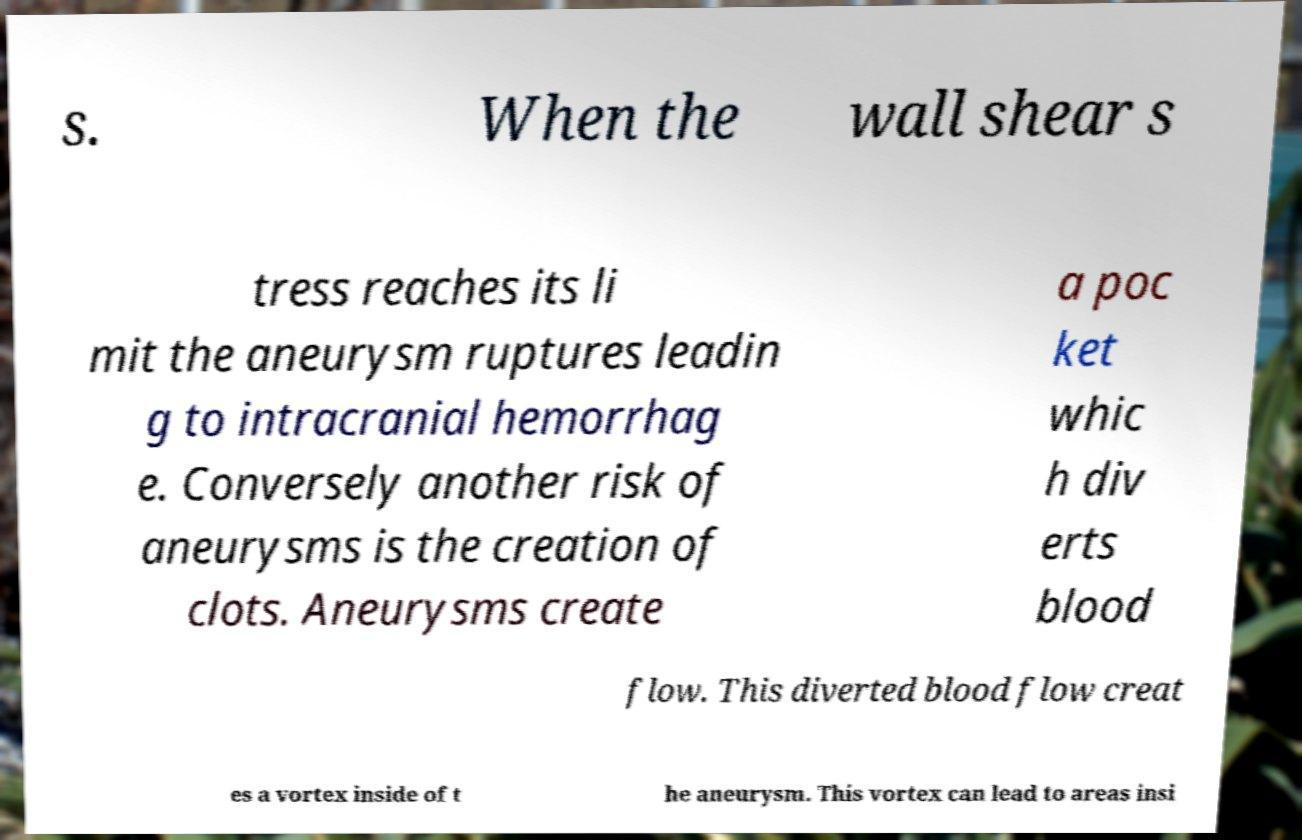Can you accurately transcribe the text from the provided image for me? s. When the wall shear s tress reaches its li mit the aneurysm ruptures leadin g to intracranial hemorrhag e. Conversely another risk of aneurysms is the creation of clots. Aneurysms create a poc ket whic h div erts blood flow. This diverted blood flow creat es a vortex inside of t he aneurysm. This vortex can lead to areas insi 